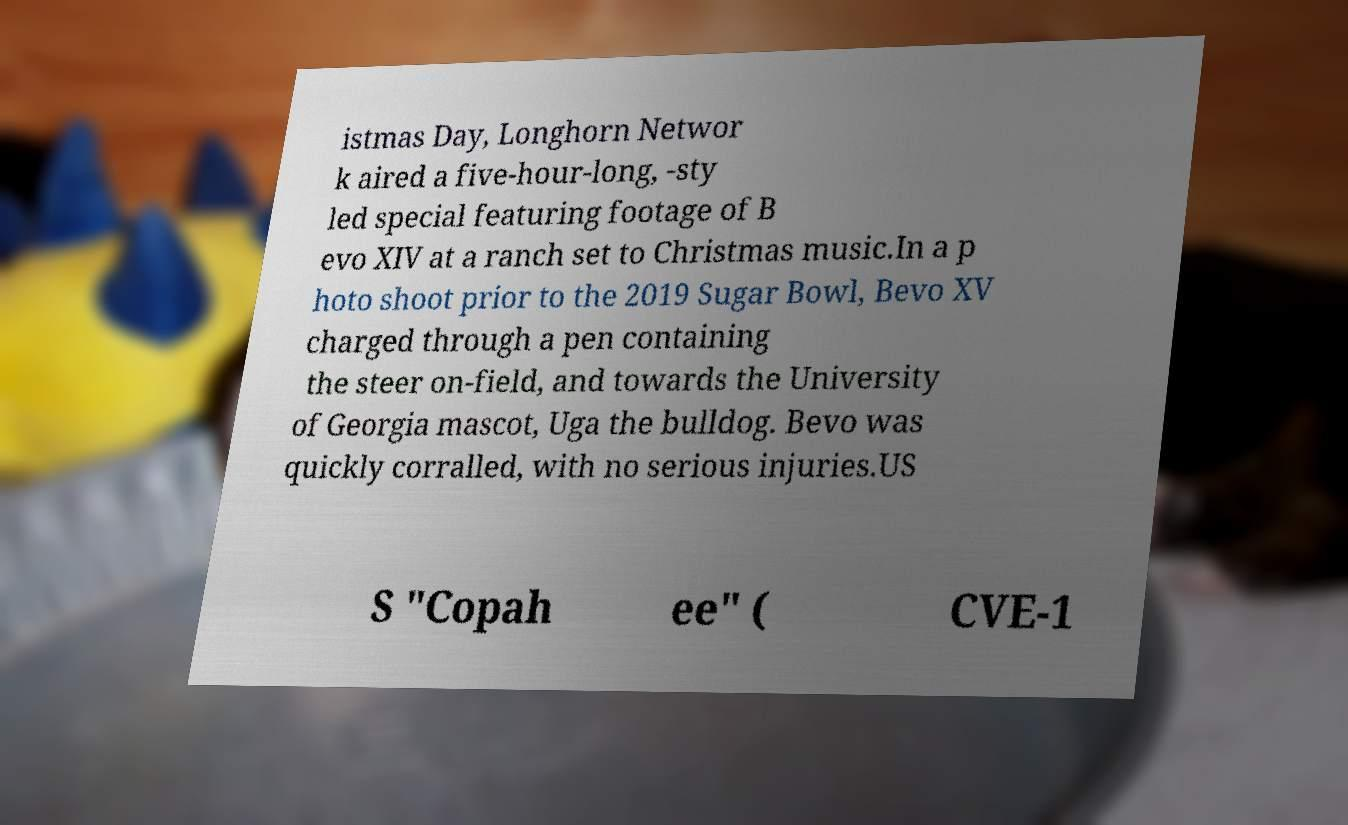Can you read and provide the text displayed in the image?This photo seems to have some interesting text. Can you extract and type it out for me? istmas Day, Longhorn Networ k aired a five-hour-long, -sty led special featuring footage of B evo XIV at a ranch set to Christmas music.In a p hoto shoot prior to the 2019 Sugar Bowl, Bevo XV charged through a pen containing the steer on-field, and towards the University of Georgia mascot, Uga the bulldog. Bevo was quickly corralled, with no serious injuries.US S "Copah ee" ( CVE-1 